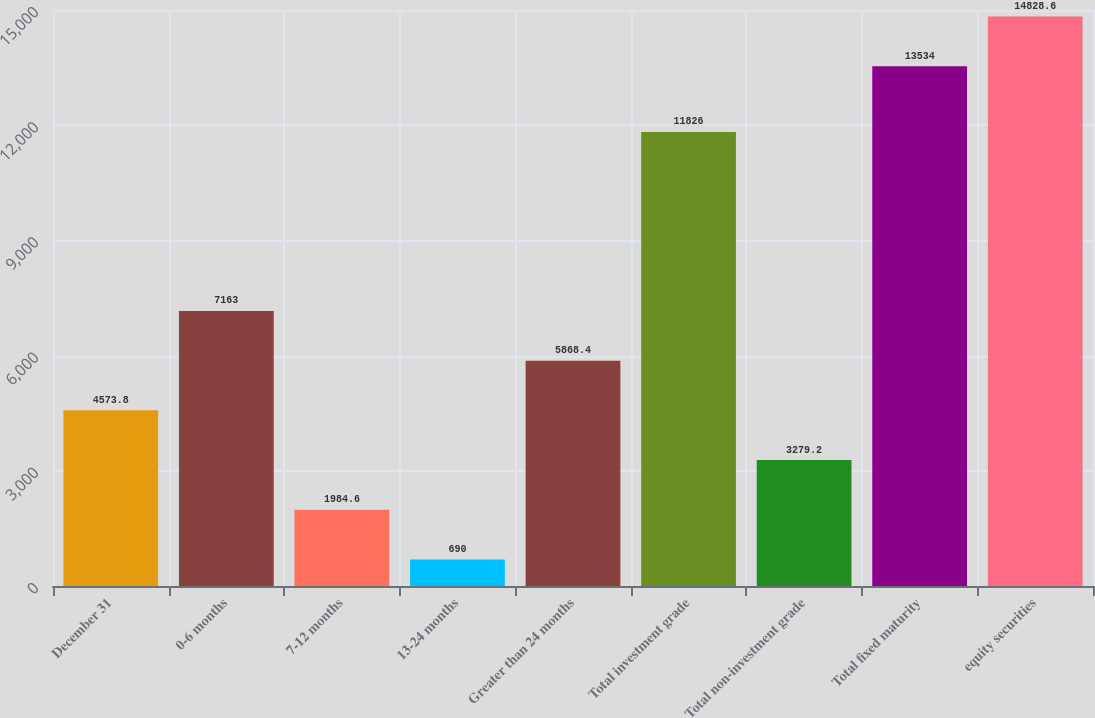Convert chart. <chart><loc_0><loc_0><loc_500><loc_500><bar_chart><fcel>December 31<fcel>0-6 months<fcel>7-12 months<fcel>13-24 months<fcel>Greater than 24 months<fcel>Total investment grade<fcel>Total non-investment grade<fcel>Total fixed maturity<fcel>equity securities<nl><fcel>4573.8<fcel>7163<fcel>1984.6<fcel>690<fcel>5868.4<fcel>11826<fcel>3279.2<fcel>13534<fcel>14828.6<nl></chart> 